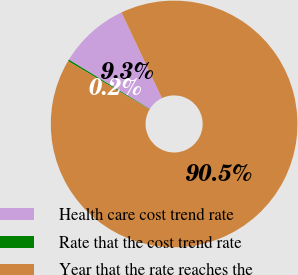<chart> <loc_0><loc_0><loc_500><loc_500><pie_chart><fcel>Health care cost trend rate<fcel>Rate that the cost trend rate<fcel>Year that the rate reaches the<nl><fcel>9.25%<fcel>0.22%<fcel>90.52%<nl></chart> 